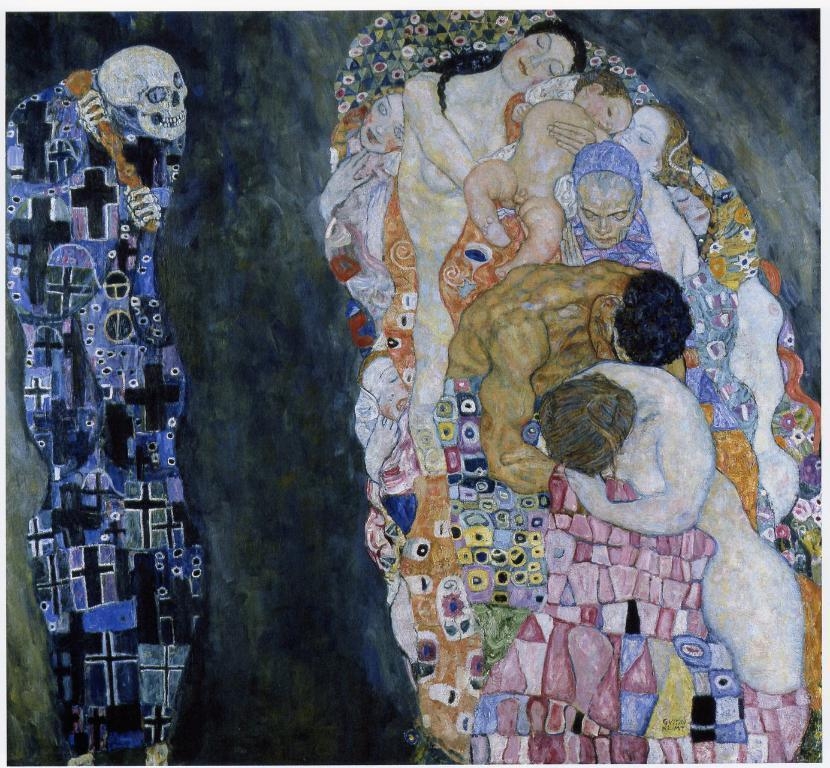What is the main subject of the painted poster in the image? The poster depicts a woman, a small baby, and a man lying together in cloth. Can you describe the scene depicted on the poster? The scene shows a woman, a small baby, and a man lying together in cloth. What is located beside the poster in the image? There is a skeleton beside the poster. How does the ice melt on the poster in the image? There is no ice present in the image, as the poster depicts a woman, a small baby, and a man lying together in cloth. What color does the skeleton change to in the image? The skeleton does not change color in the image; it remains the same color throughout. 